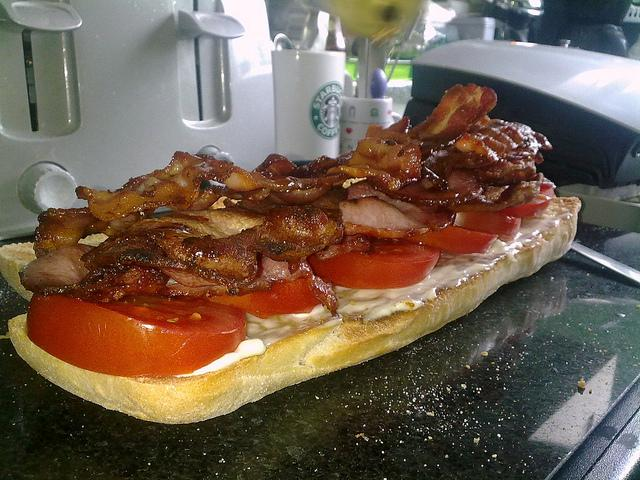What is missing to make a classic sandwich? Please explain your reasoning. lettuce. There is no lettuce on the sandwich which is needed for a blt. 